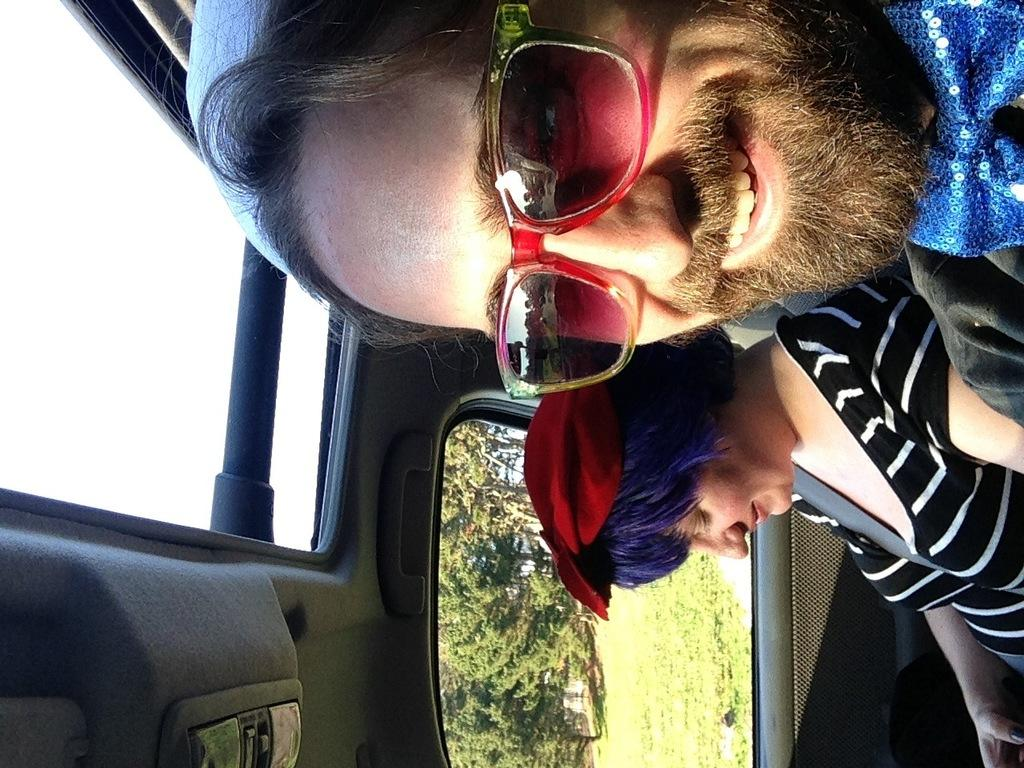What type of vehicle are the people sitting in? The people are sitting in an open top window car. Where is the car located? The car is on a ground covered with grass. What can be seen in the background of the image? There are many trees visible in the background. What type of government is depicted in the image? There is no depiction of a government in the image; it features people sitting in a car on a grassy ground with trees in the background. 